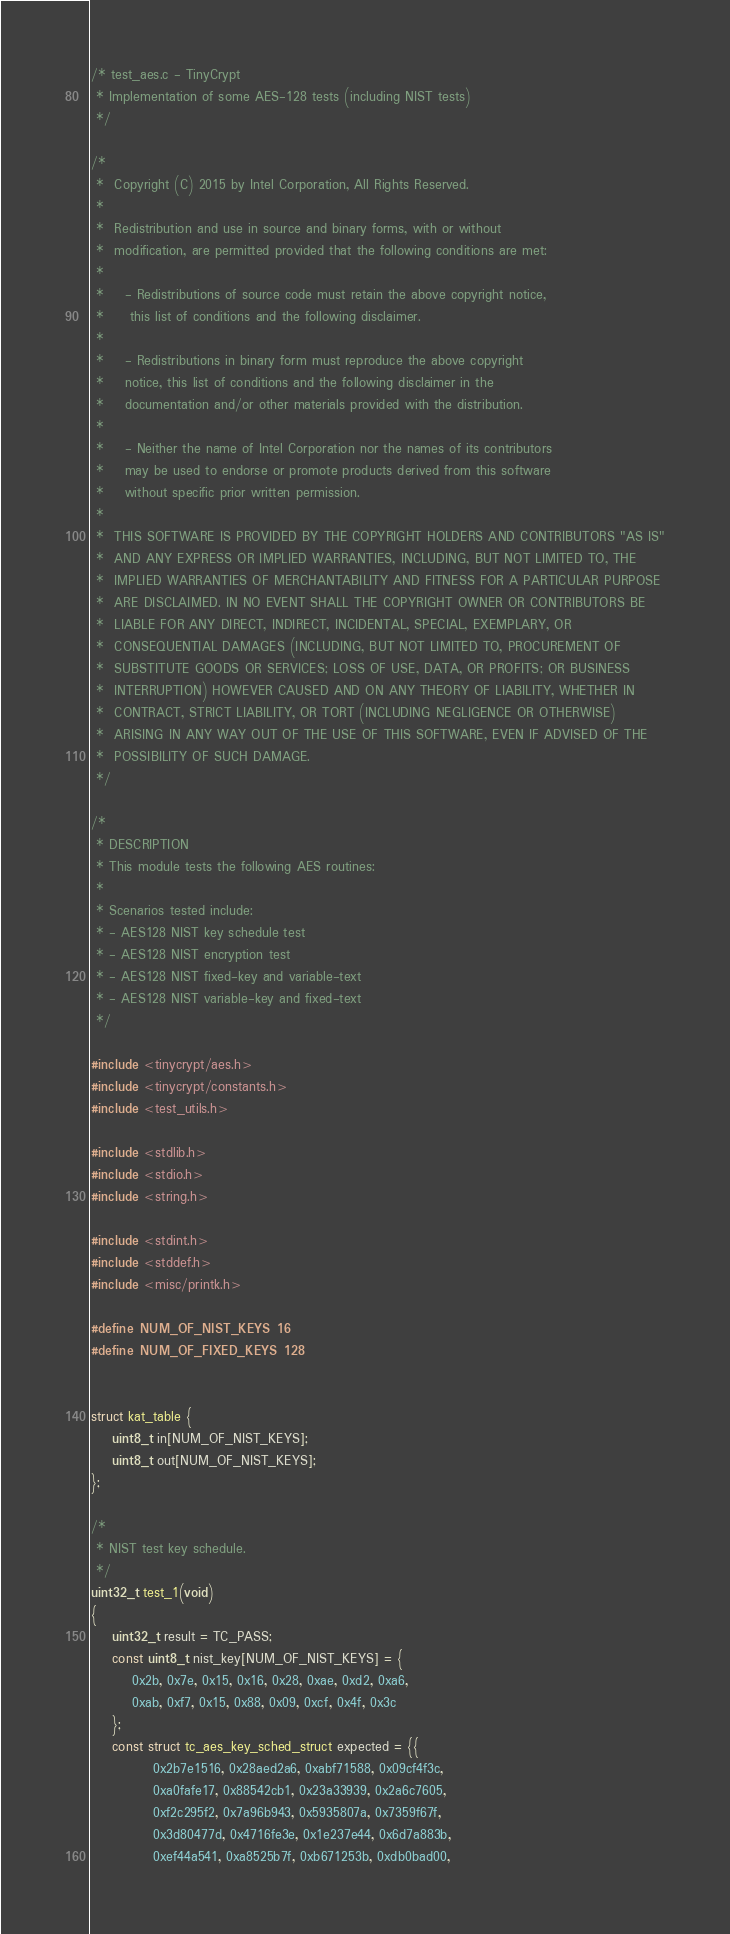Convert code to text. <code><loc_0><loc_0><loc_500><loc_500><_C_>/* test_aes.c - TinyCrypt
 * Implementation of some AES-128 tests (including NIST tests)
 */

/*
 *  Copyright (C) 2015 by Intel Corporation, All Rights Reserved.
 *
 *  Redistribution and use in source and binary forms, with or without
 *  modification, are permitted provided that the following conditions are met:
 *
 *    - Redistributions of source code must retain the above copyright notice,
 *     this list of conditions and the following disclaimer.
 *
 *    - Redistributions in binary form must reproduce the above copyright
 *    notice, this list of conditions and the following disclaimer in the
 *    documentation and/or other materials provided with the distribution.
 *
 *    - Neither the name of Intel Corporation nor the names of its contributors
 *    may be used to endorse or promote products derived from this software
 *    without specific prior written permission.
 *
 *  THIS SOFTWARE IS PROVIDED BY THE COPYRIGHT HOLDERS AND CONTRIBUTORS "AS IS"
 *  AND ANY EXPRESS OR IMPLIED WARRANTIES, INCLUDING, BUT NOT LIMITED TO, THE
 *  IMPLIED WARRANTIES OF MERCHANTABILITY AND FITNESS FOR A PARTICULAR PURPOSE
 *  ARE DISCLAIMED. IN NO EVENT SHALL THE COPYRIGHT OWNER OR CONTRIBUTORS BE
 *  LIABLE FOR ANY DIRECT, INDIRECT, INCIDENTAL, SPECIAL, EXEMPLARY, OR
 *  CONSEQUENTIAL DAMAGES (INCLUDING, BUT NOT LIMITED TO, PROCUREMENT OF
 *  SUBSTITUTE GOODS OR SERVICES; LOSS OF USE, DATA, OR PROFITS; OR BUSINESS
 *  INTERRUPTION) HOWEVER CAUSED AND ON ANY THEORY OF LIABILITY, WHETHER IN
 *  CONTRACT, STRICT LIABILITY, OR TORT (INCLUDING NEGLIGENCE OR OTHERWISE)
 *  ARISING IN ANY WAY OUT OF THE USE OF THIS SOFTWARE, EVEN IF ADVISED OF THE
 *  POSSIBILITY OF SUCH DAMAGE.
 */

/*
 * DESCRIPTION
 * This module tests the following AES routines:
 *
 * Scenarios tested include:
 * - AES128 NIST key schedule test
 * - AES128 NIST encryption test
 * - AES128 NIST fixed-key and variable-text
 * - AES128 NIST variable-key and fixed-text
 */

#include <tinycrypt/aes.h>
#include <tinycrypt/constants.h>
#include <test_utils.h>

#include <stdlib.h>
#include <stdio.h>
#include <string.h>

#include <stdint.h>
#include <stddef.h>
#include <misc/printk.h>

#define NUM_OF_NIST_KEYS 16
#define NUM_OF_FIXED_KEYS 128


struct kat_table {
	uint8_t in[NUM_OF_NIST_KEYS];
	uint8_t out[NUM_OF_NIST_KEYS];
};

/*
 * NIST test key schedule.
 */
uint32_t test_1(void)
{
	uint32_t result = TC_PASS;
	const uint8_t nist_key[NUM_OF_NIST_KEYS] = {
		0x2b, 0x7e, 0x15, 0x16, 0x28, 0xae, 0xd2, 0xa6,
		0xab, 0xf7, 0x15, 0x88, 0x09, 0xcf, 0x4f, 0x3c
	};
	const struct tc_aes_key_sched_struct expected = {{
			0x2b7e1516, 0x28aed2a6, 0xabf71588, 0x09cf4f3c,
			0xa0fafe17, 0x88542cb1, 0x23a33939, 0x2a6c7605,
			0xf2c295f2, 0x7a96b943, 0x5935807a, 0x7359f67f,
			0x3d80477d, 0x4716fe3e, 0x1e237e44, 0x6d7a883b,
			0xef44a541, 0xa8525b7f, 0xb671253b, 0xdb0bad00,</code> 